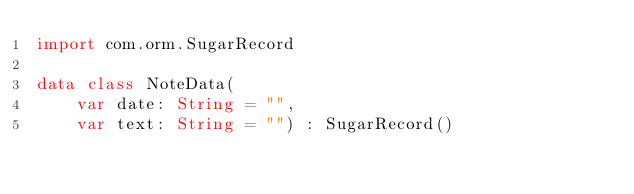Convert code to text. <code><loc_0><loc_0><loc_500><loc_500><_Kotlin_>import com.orm.SugarRecord

data class NoteData(
    var date: String = "",
    var text: String = "") : SugarRecord()
</code> 